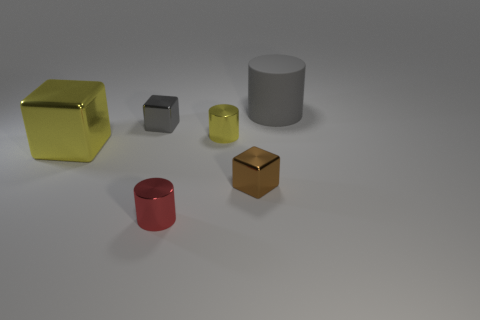Subtract all small red metallic cylinders. How many cylinders are left? 2 Add 1 brown rubber cylinders. How many objects exist? 7 Subtract all red cylinders. How many cylinders are left? 2 Subtract 3 cylinders. How many cylinders are left? 0 Subtract all brown cylinders. Subtract all purple cubes. How many cylinders are left? 3 Subtract all yellow cylinders. How many purple blocks are left? 0 Subtract all tiny metal blocks. Subtract all brown cubes. How many objects are left? 3 Add 4 gray cubes. How many gray cubes are left? 5 Add 5 brown matte spheres. How many brown matte spheres exist? 5 Subtract 0 brown cylinders. How many objects are left? 6 